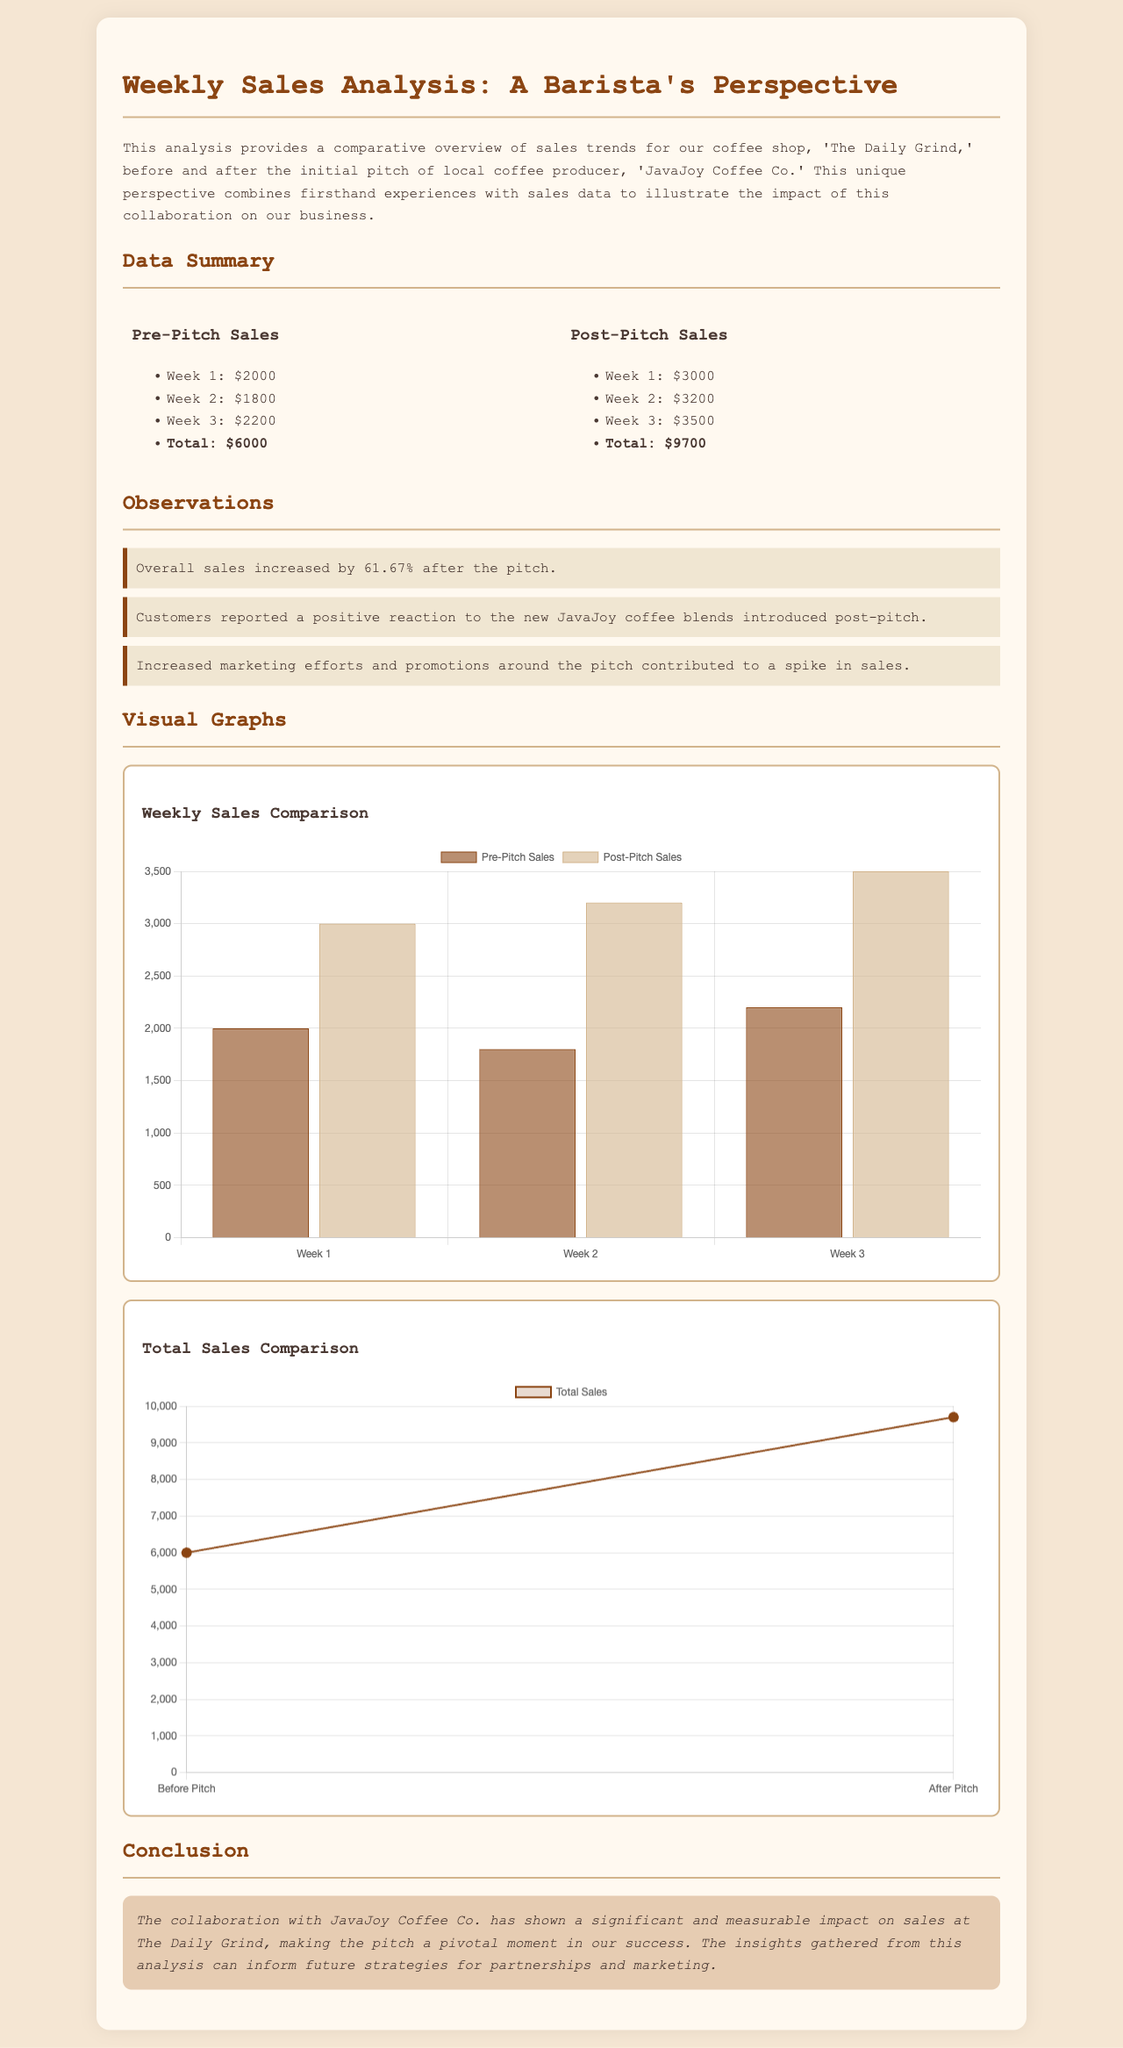What was the total sales before the pitch? The total sales before the pitch is mentioned as $6000 in the document.
Answer: $6000 What was the total sales after the pitch? The total sales after the pitch is mentioned as $9700 in the document.
Answer: $9700 What percentage increase in sales was observed after the pitch? The document states that there was a 61.67% increase in sales after the pitch.
Answer: 61.67% Which coffee producer is featured in the analysis? The analysis mentions 'JavaJoy Coffee Co.' as the featured coffee producer.
Answer: JavaJoy Coffee Co How many weeks of sales data are compared in the analysis? The analysis compares sales data over three weeks before and after the pitch.
Answer: Three weeks What type of chart is used to depict weekly sales comparison? The document indicates that a bar chart is used for the weekly sales comparison.
Answer: Bar chart What significant effect did the pitch have on customer reaction? The document notes that customers reported a positive reaction to the new coffee blends introduced post-pitch.
Answer: Positive reaction What is the style of the conclusion in the analysis? The conclusion has been described as italicized in the document.
Answer: Italicized What is the main focus of the analysis? The focus of the analysis is on comparing sales trends before and after the producer's first pitch.
Answer: Comparing sales trends 